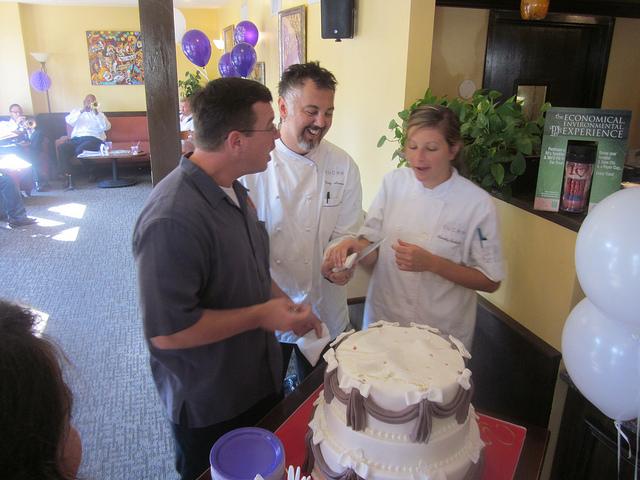What color nose does the biggest one have?
Answer briefly. White. What color are the flower petals on the table?
Write a very short answer. White. Is that a type of food normally seen at weddings?
Give a very brief answer. Yes. What kind of food do they mean hold?
Short answer required. Cake. Who are these people cutting the cake?
Answer briefly. Chefs. Is the woman wearing a ring?
Give a very brief answer. No. How many people are here?
Short answer required. 6. Does these mean belong to the same group?
Concise answer only. Yes. Are the two people in white coats surprised?
Write a very short answer. Yes. 